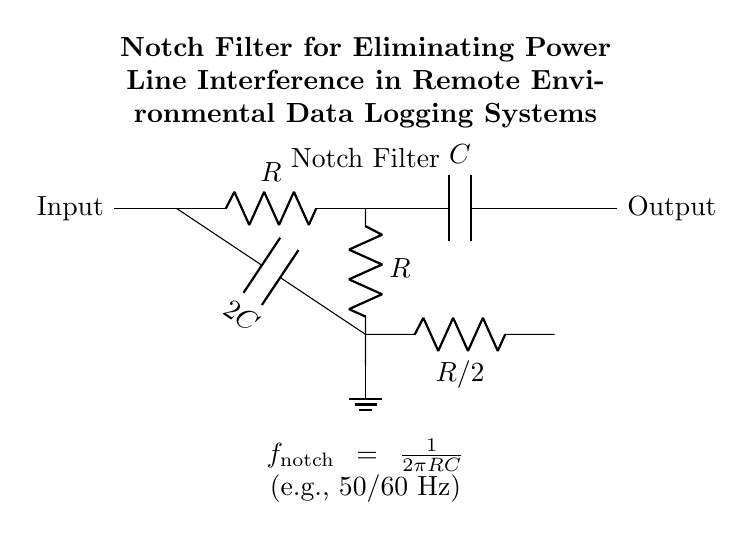What is the type of filter represented in the circuit? The circuit diagram shows a notch filter, which is specifically designed to eliminate power line interference in signals. It is identified by the twin-T configuration of resistors and capacitors arranged to create a frequency-selective network.
Answer: Notch filter What is the value of the capacitors used in the filter? The circuit features two capacitors: one is labeled C and the other is labeled 2C, indicating a value that is double the first capacitor. The specific numerical value isn't provided but the labels communicate the relative values.
Answer: C and 2C What is the elimination frequency for this notch filter? The frequency at which this notch filter operates is determined by the formula given in the annotations: f_notch = 1/(2πRC). Since the filter targets power line frequencies, it usually eliminates either 50 or 60 Hz based on the application.
Answer: 50/60 Hz What connections exist between the components? The circuit shows multiple connections between the resistors and capacitors. Specifically, there are direct connections along the voltage path from input to output, forming a loop through R, C, and another configuration with R/2 and 2C.
Answer: Input to output with resistors and capacitors connected What value of resistance is represented in the circuit? The circuit specifies multiple resistors: R and R/2. Without specific numerical values provided for R, the answer focuses on the relationship outlined in the circuit. R represents one resistance, and R/2 indicates another that is half of R.
Answer: R and R/2 What is the purpose of the ground connection in this circuit? The ground connection serves as a reference point for the zero voltage in the circuit, ensuring the stability of the circuit operation and providing a return path for electric current, particularly important in environmental data logging to avoid noise.
Answer: Reference point 